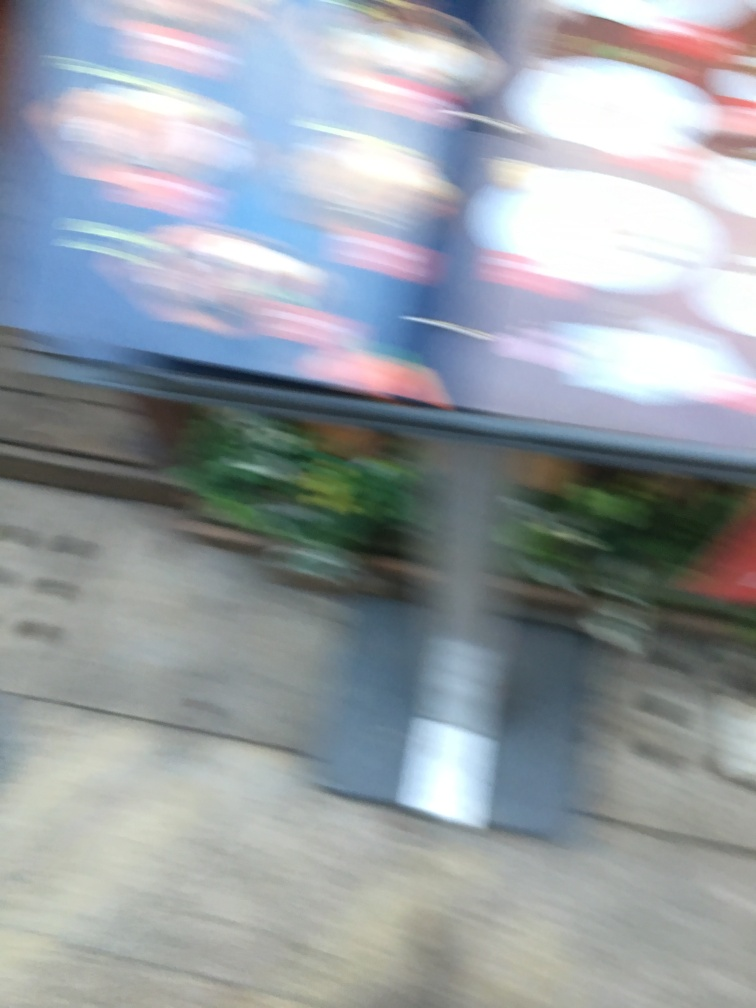Can you describe what might have caused the blurriness in this image? The blurriness could result from several factors such as camera shake during the exposure, a subject in motion, or a focus error where the camera did not lock onto the intended subject. 